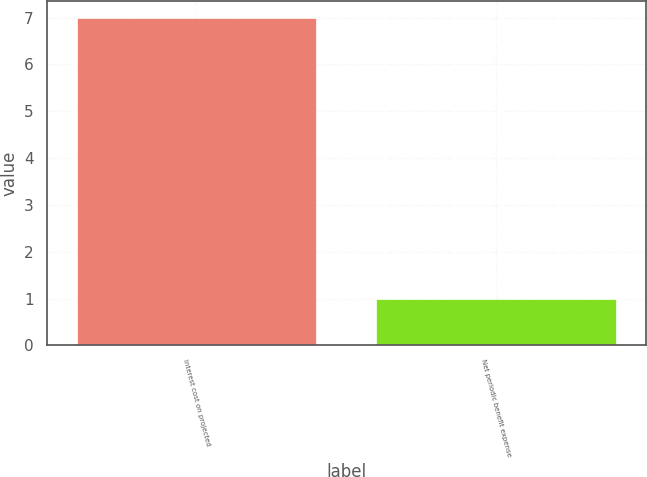<chart> <loc_0><loc_0><loc_500><loc_500><bar_chart><fcel>Interest cost on projected<fcel>Net periodic benefit expense<nl><fcel>7<fcel>1<nl></chart> 